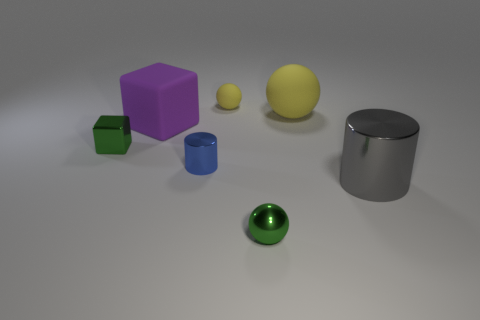How many tiny balls are the same material as the gray cylinder?
Provide a succinct answer. 1. There is a small green metal thing left of the purple rubber thing; what is its shape?
Offer a terse response. Cube. Are the big cylinder and the tiny sphere that is behind the large matte ball made of the same material?
Ensure brevity in your answer.  No. Is there a red shiny ball?
Offer a very short reply. No. There is a small green shiny thing on the right side of the large rubber object that is left of the tiny green metal sphere; are there any big gray things on the right side of it?
Ensure brevity in your answer.  Yes. How many tiny objects are either blue objects or gray shiny objects?
Make the answer very short. 1. The rubber sphere that is the same size as the green metal ball is what color?
Provide a short and direct response. Yellow. What number of blue cylinders are behind the big yellow object?
Your answer should be compact. 0. Are there any green cubes that have the same material as the small blue thing?
Offer a terse response. Yes. There is a small matte object that is the same color as the big sphere; what shape is it?
Keep it short and to the point. Sphere. 